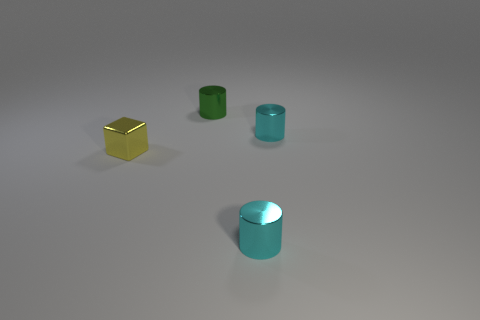Add 3 tiny cyan cylinders. How many objects exist? 7 Subtract all cubes. How many objects are left? 3 Subtract all tiny yellow shiny objects. Subtract all tiny shiny cylinders. How many objects are left? 0 Add 1 tiny green cylinders. How many tiny green cylinders are left? 2 Add 3 small gray cylinders. How many small gray cylinders exist? 3 Subtract 0 brown cylinders. How many objects are left? 4 